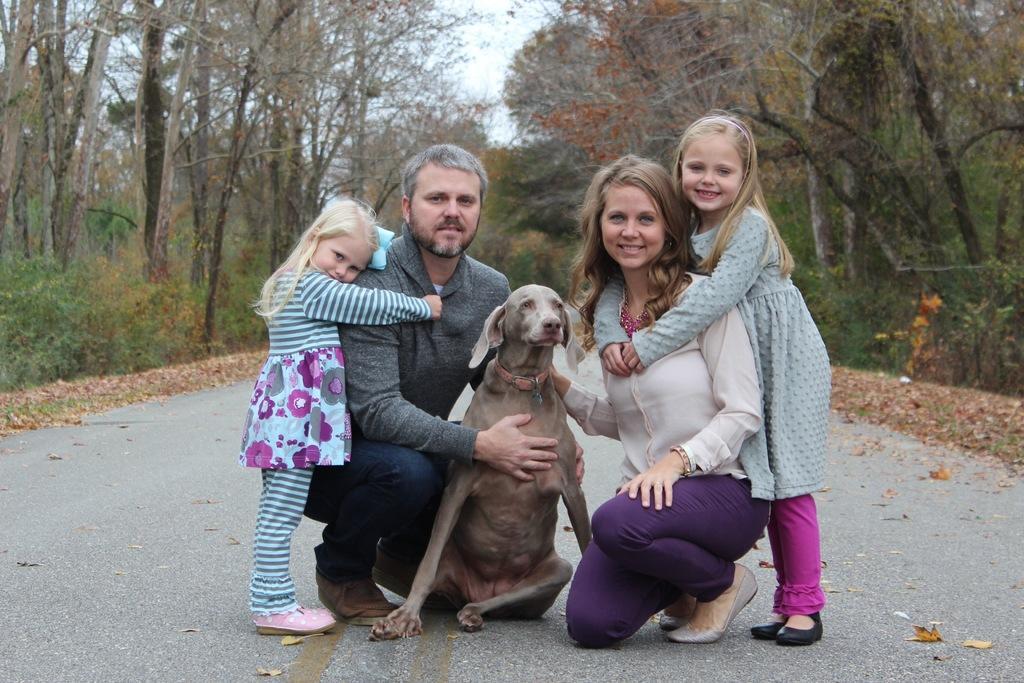How would you summarize this image in a sentence or two? There is a man woman and two girls with dog in middle of forest. 